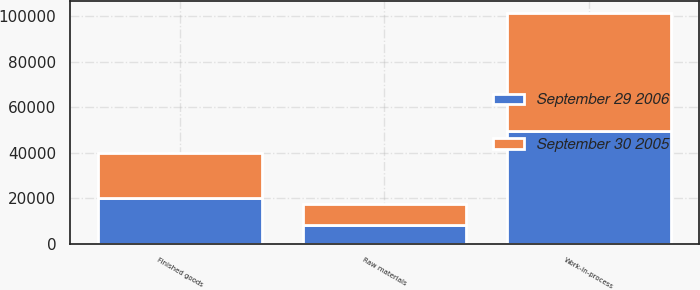Convert chart. <chart><loc_0><loc_0><loc_500><loc_500><stacked_bar_chart><ecel><fcel>Raw materials<fcel>Work-in-process<fcel>Finished goods<nl><fcel>September 30 2005<fcel>9476<fcel>52097<fcel>19956<nl><fcel>September 29 2006<fcel>8080<fcel>49329<fcel>19991<nl></chart> 